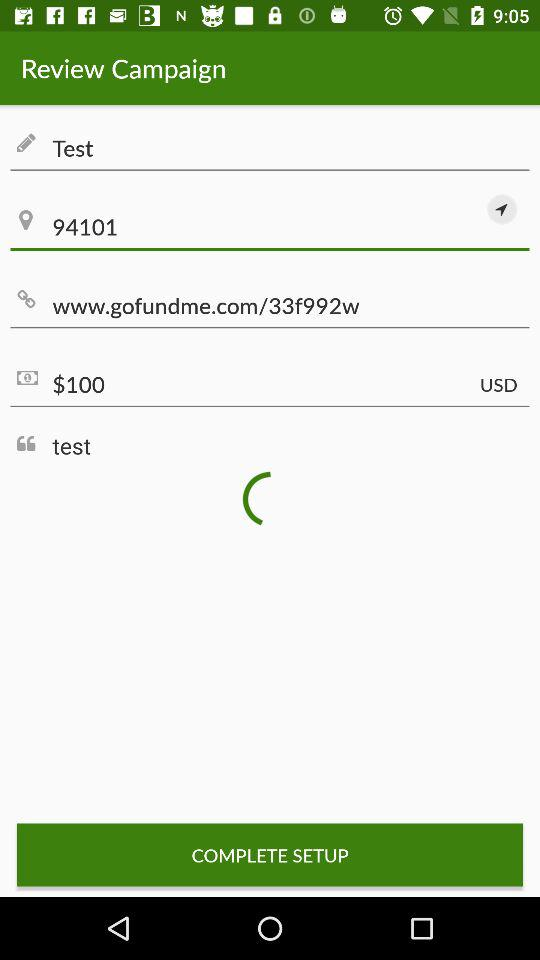What is the price given? The price given is $ 100. 